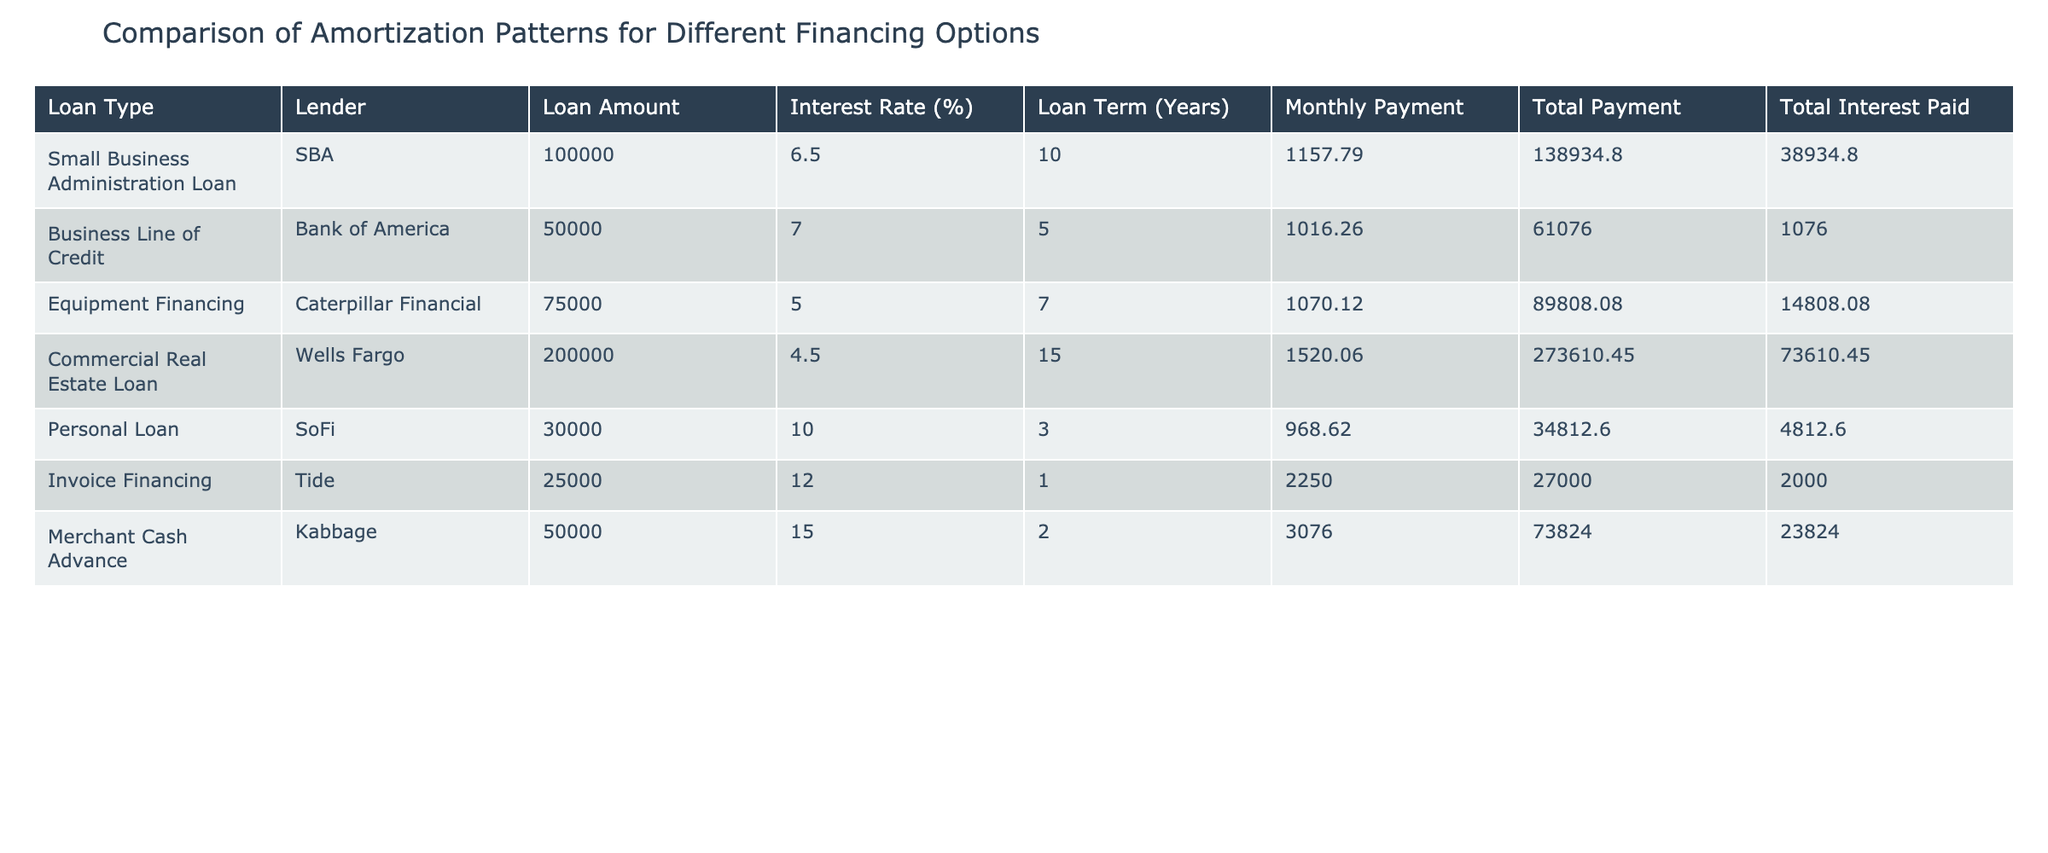What is the total loan amount for all financing options listed? To find the total loan amount, we need to sum the loan amounts from each financing option. The amounts are 100000 + 50000 + 75000 + 200000 + 30000 + 25000 + 50000 = 525000.
Answer: 525000 Which loan type has the highest total interest paid? To identify the loan type with the highest total interest paid, we compare the total interest paid values in the table. The highest value is 73610.45 associated with the Commercial Real Estate Loan.
Answer: Commercial Real Estate Loan Is the total payment for the Equipment Financing higher than the total payment for the Personal Loan? We compare the total payments: Equipment Financing has a total payment of 89808.08, while the Personal Loan has a total payment of 34812.60. Since 89808.08 is greater than 34812.60, the statement is true.
Answer: Yes What is the average monthly payment among all the loans? First, we must find the monthly payment for each loan and then calculate the average. The monthly payments are: 1157.79, 1016.26, 1070.12, 1520.06, 968.62, 2250.00, and 3076.00. The sum is 1157.79 + 1016.26 + 1070.12 + 1520.06 + 968.62 + 2250.00 + 3076.00 = 11858.85. As there are 7 loans, we then divide by 7: 11858.85 / 7 ≈ 1694.10.
Answer: 1694.10 Which loan type offers the lowest interest rate, and what is its amount? By examining the interest rates, we see that the Equipment Financing has the lowest interest rate at 5.0%. The loan amount for this option is 75000.
Answer: Equipment Financing, 75000 